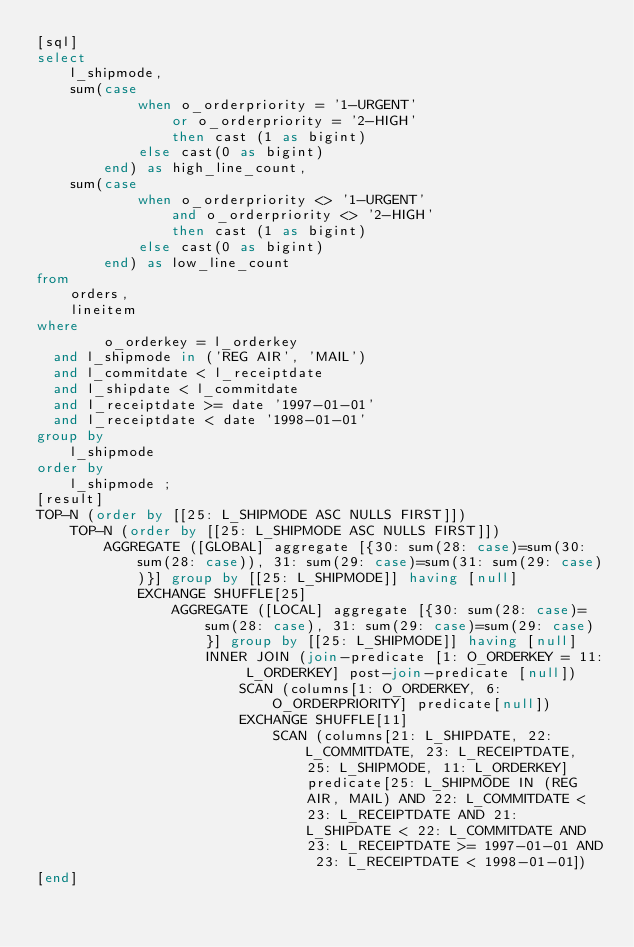<code> <loc_0><loc_0><loc_500><loc_500><_SQL_>[sql]
select
    l_shipmode,
    sum(case
            when o_orderpriority = '1-URGENT'
                or o_orderpriority = '2-HIGH'
                then cast (1 as bigint)
            else cast(0 as bigint)
        end) as high_line_count,
    sum(case
            when o_orderpriority <> '1-URGENT'
                and o_orderpriority <> '2-HIGH'
                then cast (1 as bigint)
            else cast(0 as bigint)
        end) as low_line_count
from
    orders,
    lineitem
where
        o_orderkey = l_orderkey
  and l_shipmode in ('REG AIR', 'MAIL')
  and l_commitdate < l_receiptdate
  and l_shipdate < l_commitdate
  and l_receiptdate >= date '1997-01-01'
  and l_receiptdate < date '1998-01-01'
group by
    l_shipmode
order by
    l_shipmode ;
[result]
TOP-N (order by [[25: L_SHIPMODE ASC NULLS FIRST]])
    TOP-N (order by [[25: L_SHIPMODE ASC NULLS FIRST]])
        AGGREGATE ([GLOBAL] aggregate [{30: sum(28: case)=sum(30: sum(28: case)), 31: sum(29: case)=sum(31: sum(29: case))}] group by [[25: L_SHIPMODE]] having [null]
            EXCHANGE SHUFFLE[25]
                AGGREGATE ([LOCAL] aggregate [{30: sum(28: case)=sum(28: case), 31: sum(29: case)=sum(29: case)}] group by [[25: L_SHIPMODE]] having [null]
                    INNER JOIN (join-predicate [1: O_ORDERKEY = 11: L_ORDERKEY] post-join-predicate [null])
                        SCAN (columns[1: O_ORDERKEY, 6: O_ORDERPRIORITY] predicate[null])
                        EXCHANGE SHUFFLE[11]
                            SCAN (columns[21: L_SHIPDATE, 22: L_COMMITDATE, 23: L_RECEIPTDATE, 25: L_SHIPMODE, 11: L_ORDERKEY] predicate[25: L_SHIPMODE IN (REG AIR, MAIL) AND 22: L_COMMITDATE < 23: L_RECEIPTDATE AND 21: L_SHIPDATE < 22: L_COMMITDATE AND 23: L_RECEIPTDATE >= 1997-01-01 AND 23: L_RECEIPTDATE < 1998-01-01])
[end]

</code> 